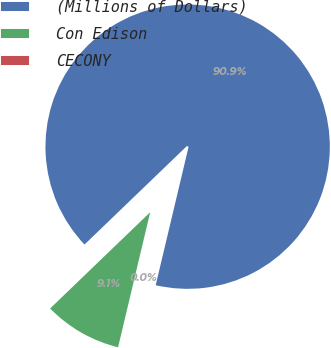Convert chart. <chart><loc_0><loc_0><loc_500><loc_500><pie_chart><fcel>(Millions of Dollars)<fcel>Con Edison<fcel>CECONY<nl><fcel>90.9%<fcel>9.09%<fcel>0.0%<nl></chart> 